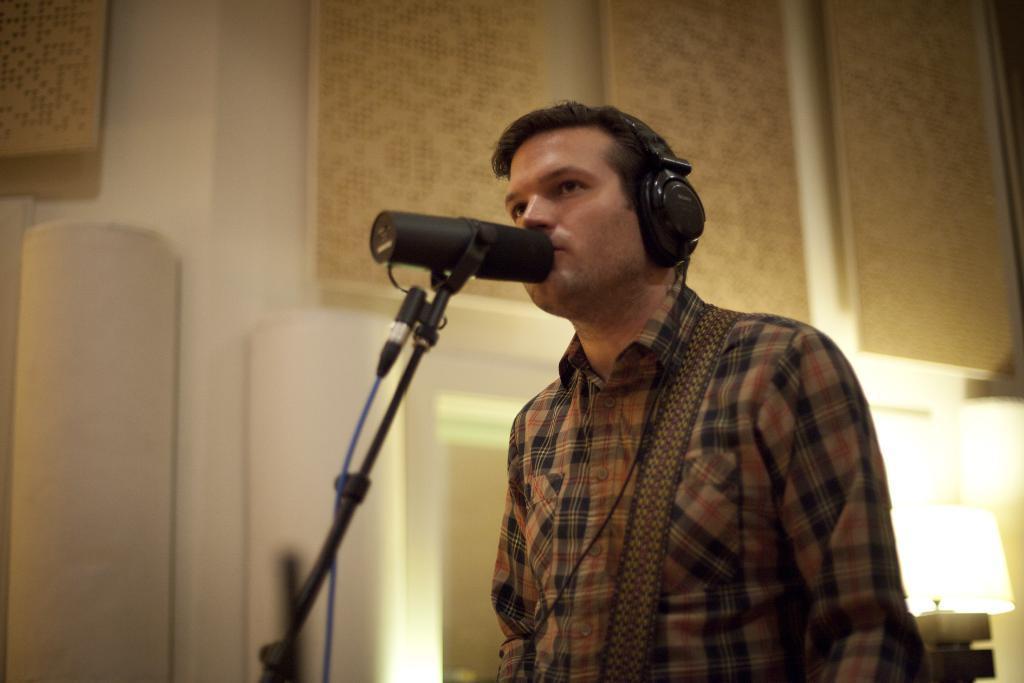How would you summarize this image in a sentence or two? In this image a person is wearing headsets. Before him there is a mike stand. Right bottom there is a lamp. Background there is a wall. 